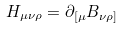<formula> <loc_0><loc_0><loc_500><loc_500>H _ { \mu \nu \rho } = \partial _ { [ \mu } B _ { \nu \rho ] }</formula> 